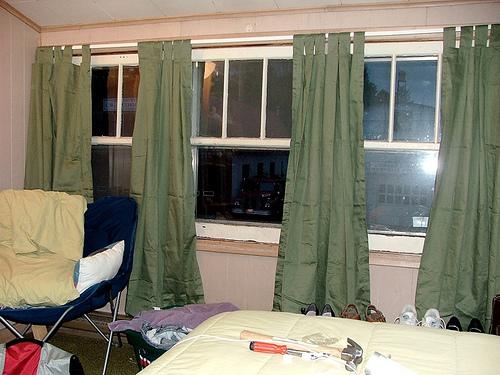Do you see a hammer?
Concise answer only. Yes. Have the curtains been ironed?
Be succinct. No. How many windows are open?
Concise answer only. 1. 